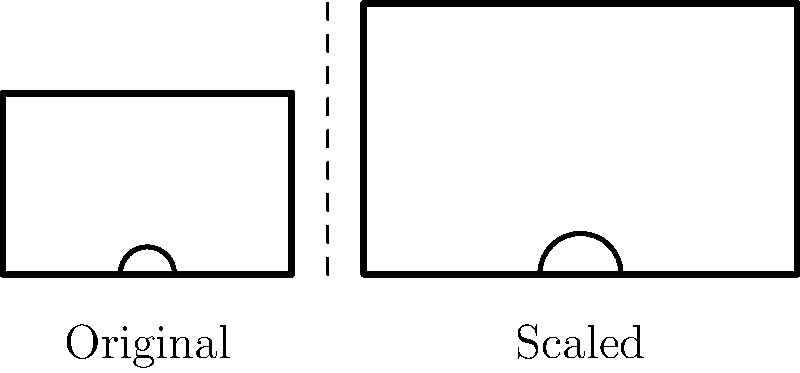In a new basketball arena design, the dimensions of the backboard are being scaled up by a factor of 1.5. If the original backboard is 80 inches wide and 50 inches tall, what will be the area of the new, scaled-up backboard in square inches? Let's approach this step-by-step:

1) First, recall the formula for the area of a rectangle:
   $A = w \times h$, where $w$ is width and $h$ is height.

2) The original dimensions are:
   Width ($w$) = 80 inches
   Height ($h$) = 50 inches

3) The original area is:
   $A_{original} = 80 \times 50 = 4000$ square inches

4) Now, we're scaling both dimensions by a factor of 1.5. This means:
   New width = $80 \times 1.5 = 120$ inches
   New height = $50 \times 1.5 = 75$ inches

5) The new area will be:
   $A_{new} = 120 \times 75 = 9000$ square inches

6) We can also think about this in terms of the scaling factor:
   When we scale both dimensions by 1.5, we're actually scaling the area by $1.5^2 = 2.25$

7) We can verify: $4000 \times 2.25 = 9000$

Therefore, the area of the new, scaled-up backboard is 9000 square inches.
Answer: 9000 square inches 